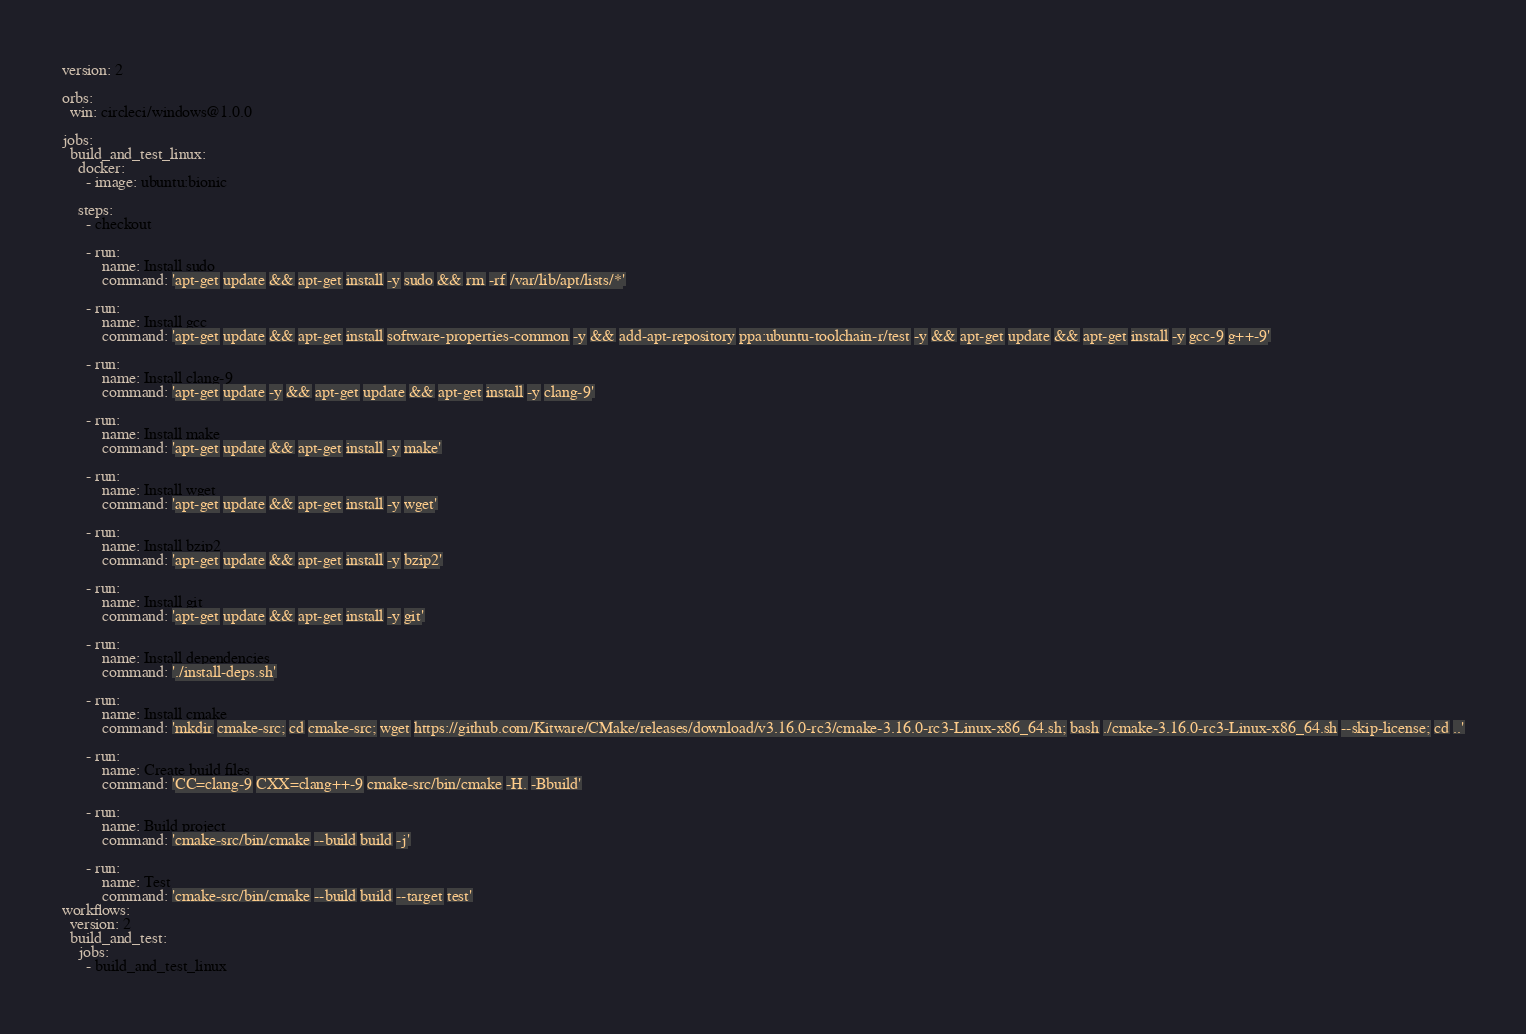Convert code to text. <code><loc_0><loc_0><loc_500><loc_500><_YAML_>version: 2

orbs:
  win: circleci/windows@1.0.0

jobs:
  build_and_test_linux:
    docker:
      - image: ubuntu:bionic

    steps:
      - checkout

      - run:
          name: Install sudo
          command: 'apt-get update && apt-get install -y sudo && rm -rf /var/lib/apt/lists/*'

      - run:
          name: Install gcc
          command: 'apt-get update && apt-get install software-properties-common -y && add-apt-repository ppa:ubuntu-toolchain-r/test -y && apt-get update && apt-get install -y gcc-9 g++-9'

      - run:
          name: Install clang-9
          command: 'apt-get update -y && apt-get update && apt-get install -y clang-9'

      - run:
          name: Install make
          command: 'apt-get update && apt-get install -y make'

      - run:
          name: Install wget
          command: 'apt-get update && apt-get install -y wget'

      - run:
          name: Install bzip2
          command: 'apt-get update && apt-get install -y bzip2'

      - run:
          name: Install git
          command: 'apt-get update && apt-get install -y git'

      - run:
          name: Install dependencies
          command: './install-deps.sh'

      - run:
          name: Install cmake
          command: 'mkdir cmake-src; cd cmake-src; wget https://github.com/Kitware/CMake/releases/download/v3.16.0-rc3/cmake-3.16.0-rc3-Linux-x86_64.sh; bash ./cmake-3.16.0-rc3-Linux-x86_64.sh --skip-license; cd ..'

      - run:
          name: Create build files
          command: 'CC=clang-9 CXX=clang++-9 cmake-src/bin/cmake -H. -Bbuild'

      - run:
          name: Build project
          command: 'cmake-src/bin/cmake --build build -j'

      - run:
          name: Test
          command: 'cmake-src/bin/cmake --build build --target test'
workflows:
  version: 2
  build_and_test:
    jobs:
      - build_and_test_linux

</code> 